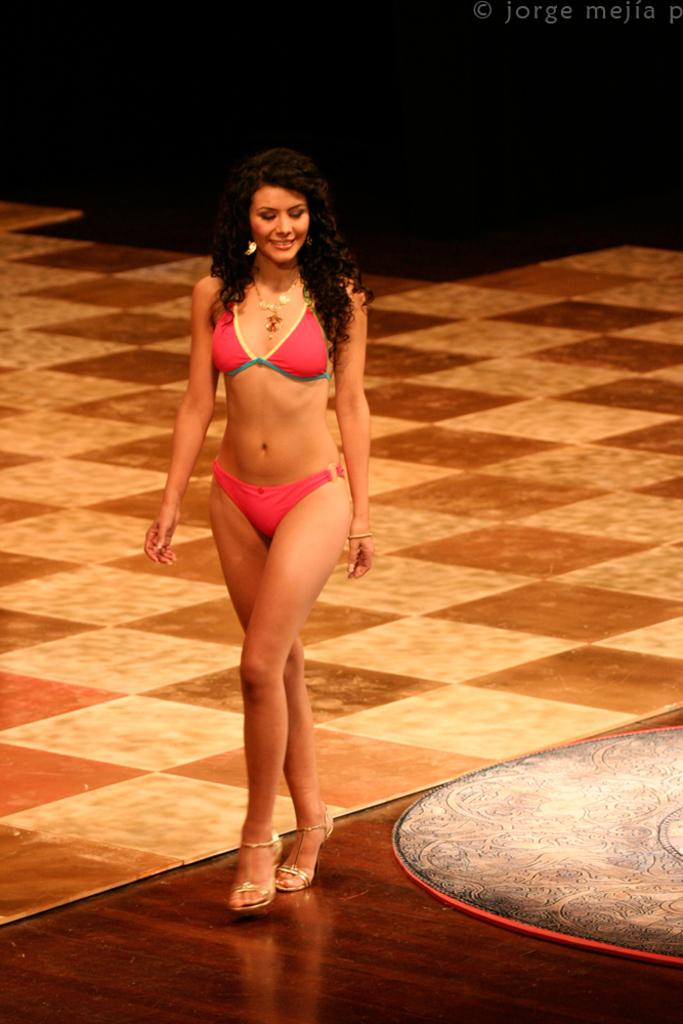What is the main subject in the foreground of the image? There is a woman on the stage in the foreground. What can be seen in the background of the image? There is a floor visible in the background, along with some text. Where was the image taken? The image was taken in a hall. How many attempts did the woman make to jump downtown in the image? There is no indication of the woman attempting to jump downtown in the image. 